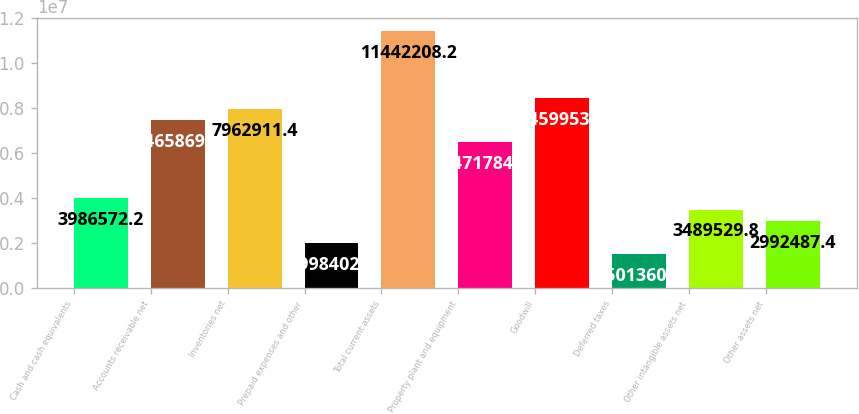Convert chart to OTSL. <chart><loc_0><loc_0><loc_500><loc_500><bar_chart><fcel>Cash and cash equivalents<fcel>Accounts receivable net<fcel>Inventories net<fcel>Prepaid expenses and other<fcel>Total current assets<fcel>Property plant and equipment<fcel>Goodwill<fcel>Deferred taxes<fcel>Other intangible assets net<fcel>Other assets net<nl><fcel>3.98657e+06<fcel>7.46587e+06<fcel>7.96291e+06<fcel>1.9984e+06<fcel>1.14422e+07<fcel>6.47178e+06<fcel>8.45995e+06<fcel>1.50136e+06<fcel>3.48953e+06<fcel>2.99249e+06<nl></chart> 